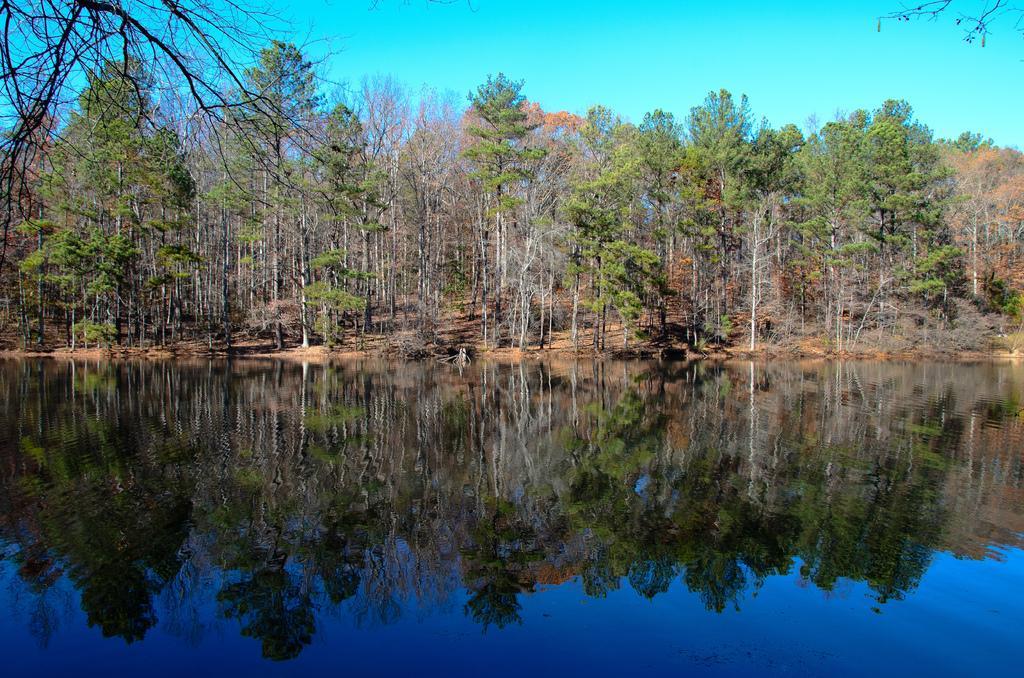Please provide a concise description of this image. In this picture we can see trees on the ground, water and in the background we can see the sky. 